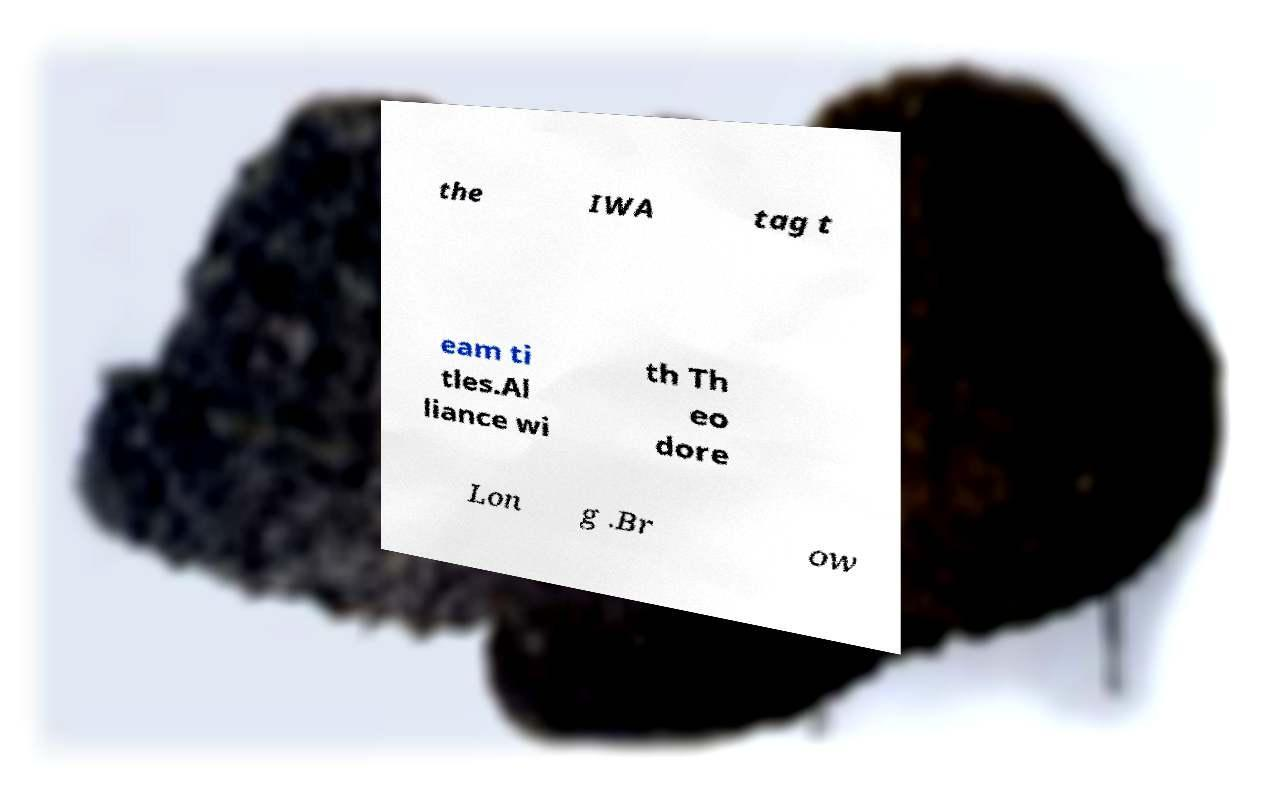Could you extract and type out the text from this image? the IWA tag t eam ti tles.Al liance wi th Th eo dore Lon g .Br ow 